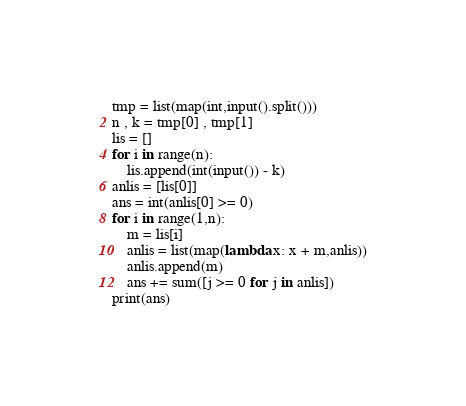Convert code to text. <code><loc_0><loc_0><loc_500><loc_500><_Python_>tmp = list(map(int,input().split()))
n , k = tmp[0] , tmp[1]
lis = []
for i in range(n):
    lis.append(int(input()) - k)
anlis = [lis[0]]
ans = int(anlis[0] >= 0)
for i in range(1,n):
    m = lis[i]
    anlis = list(map(lambda x: x + m,anlis))
    anlis.append(m)
    ans += sum([j >= 0 for j in anlis])
print(ans)
</code> 